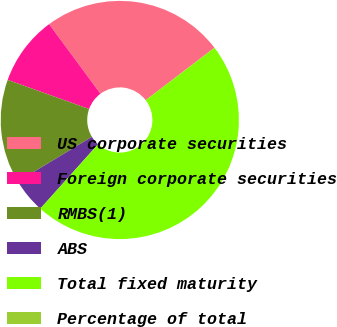Convert chart to OTSL. <chart><loc_0><loc_0><loc_500><loc_500><pie_chart><fcel>US corporate securities<fcel>Foreign corporate securities<fcel>RMBS(1)<fcel>ABS<fcel>Total fixed maturity<fcel>Percentage of total<nl><fcel>24.74%<fcel>9.42%<fcel>14.11%<fcel>4.72%<fcel>46.99%<fcel>0.02%<nl></chart> 